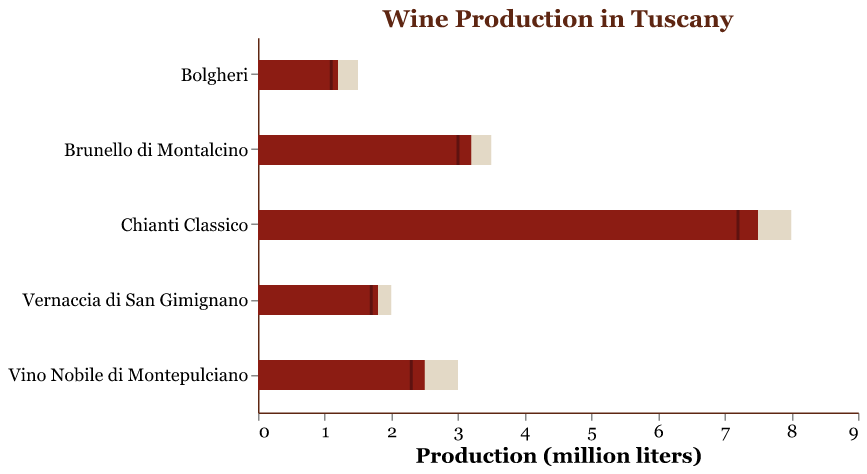what is the title of the chart? The title of the chart is positioned at the top center and is written in a larger font size. It reads "Wine Production in Tuscany" which is quite clear and straightforward to identify.
Answer: Wine Production in Tuscany How many types of wine are presented in the chart? By counting the number of different wines listed on the y-axis of the chart, we can determine the number of types of wine presented. There are five wines: Chianti Classico, Brunello di Montalcino, Vernaccia di San Gimignano, Vino Nobile di Montepulciano, and Bolgheri.
Answer: Five What is the actual production of Chianti Classico? To determine the actual production of Chianti Classico, we look at the length of the red bar for this wine, which indicates the actual value. The red bar ends at 7.5 million liters.
Answer: 7.5 million liters Which wine had the smallest production goal? We compare the lengths of the beige bars, which represent the production goals for each wine. Bolgheri has the shortest beige bar, indicating it had the smallest production goal.
Answer: Bolgheri By how much did Vino Nobile di Montepulciano miss its production goal? The production goal for Vino Nobile di Montepulciano is represented by the end of its beige bar at 3.0 million liters, and the actual production is represented by the end of its red bar at 2.5 million liters. The missing amount is calculated as 3.0 - 2.5 = 0.5 million liters.
Answer: 0.5 million liters Which wine had the highest increase in production compared to the previous year? We calculate the difference between the actual production and previous year's production for each wine. The largest difference is for Chianti Classico: 7.5 million liters (actual) - 7.2 million liters (previous year) = 0.3 million liters. This is the highest increase among the wines listed.
Answer: Chianti Classico Did Brunello di Montalcino meet its production goal? To determine if Brunello di Montalcino met its goal, we compare the red bar (actual production) to the beige bar (goal). The actual production of 3.2 million liters falls short of the goal of 3.5 million liters.
Answer: No How does the production of Vernaccia di San Gimignano this year compare to last year? The comparison is made by looking at the red bar (this year) and the small tick mark (last year). This year's production is 1.8 million liters and last year's production is 1.7 million liters. Thus, production increased by 0.1 million liters.
Answer: Increased by 0.1 million liters Which wines produced more than their previous year but did not meet the goal? We need to identify wines whose actual production (red bar) is greater than the previous year's production (tick mark) but less than the goal (beige bar). Both Vino Nobile di Montepulciano (2.5 actual vs. 2.3 previous, goal 3.0) and Vernaccia di San Gimignano (1.8 actual vs. 1.7 previous, goal 2.0) fit these criteria.
Answer: Vino Nobile di Montepulciano and Vernaccia di San Gimignano 